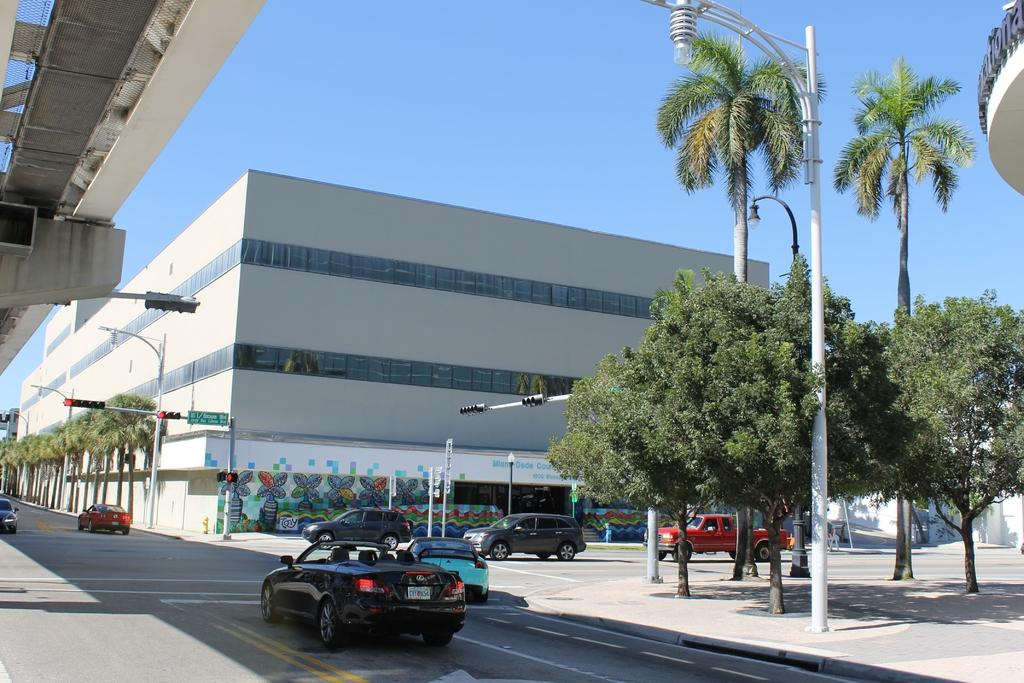What type of structure can be seen in the image? There is a flyover in the image. What can be seen in the sky in the image? The sky is visible in the image. What type of buildings are present in the image? There are buildings in the image. What type of lighting is present in the image? Street lights are present in the image. What type of poles are visible in the image? Street poles and traffic poles are visible in the image. What type of traffic control devices are present in the image? Traffic signals are present in the image. What type of signage is visible in the image? Sign boards are visible in the image. What type of vehicles can be seen on the road in the image? Motor vehicles are on the road in the image. What type of vegetation is present in the image? Trees are present in the image. What type of grills are visible in the image? Grills are visible in the image. How does the group of people increase the efficiency of the engine in the image? There is no group of people or engine present in the image. What type of engine is visible in the image? There is no engine visible in the image. 